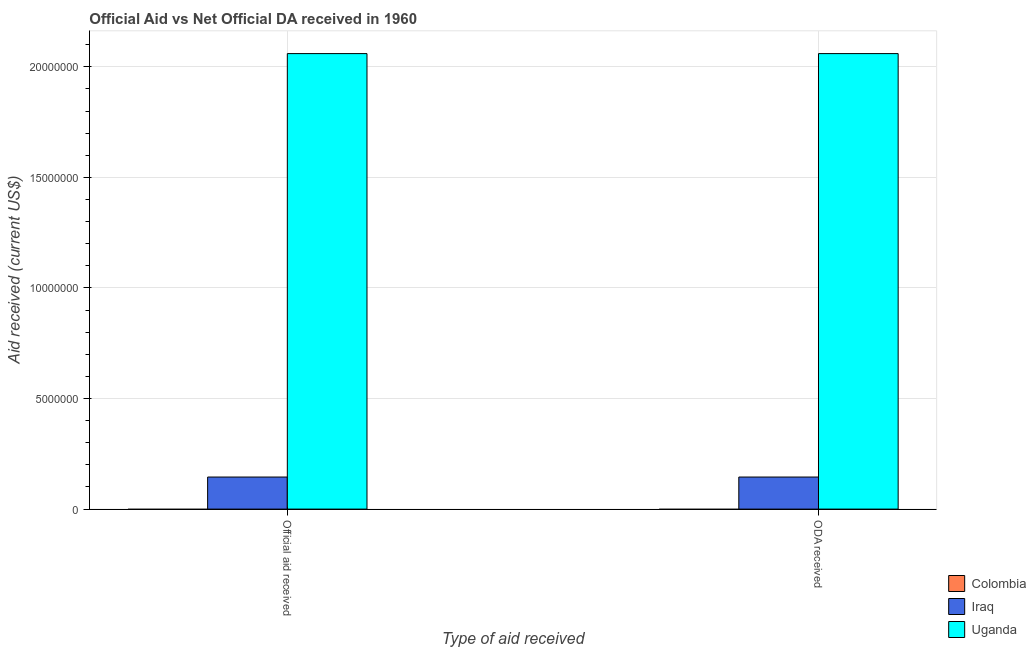Are the number of bars per tick equal to the number of legend labels?
Keep it short and to the point. No. How many bars are there on the 2nd tick from the left?
Provide a succinct answer. 2. How many bars are there on the 1st tick from the right?
Your answer should be compact. 2. What is the label of the 1st group of bars from the left?
Offer a terse response. Official aid received. What is the official aid received in Iraq?
Give a very brief answer. 1.45e+06. Across all countries, what is the maximum official aid received?
Make the answer very short. 2.06e+07. Across all countries, what is the minimum oda received?
Provide a short and direct response. 0. In which country was the oda received maximum?
Your answer should be very brief. Uganda. What is the total oda received in the graph?
Your answer should be compact. 2.20e+07. What is the difference between the official aid received in Iraq and that in Uganda?
Ensure brevity in your answer.  -1.92e+07. What is the difference between the oda received in Uganda and the official aid received in Iraq?
Give a very brief answer. 1.92e+07. What is the average official aid received per country?
Ensure brevity in your answer.  7.35e+06. What is the difference between the oda received and official aid received in Uganda?
Offer a terse response. 0. What is the ratio of the official aid received in Uganda to that in Iraq?
Provide a succinct answer. 14.21. In how many countries, is the oda received greater than the average oda received taken over all countries?
Your answer should be compact. 1. Are all the bars in the graph horizontal?
Give a very brief answer. No. How many countries are there in the graph?
Keep it short and to the point. 3. Does the graph contain any zero values?
Make the answer very short. Yes. Does the graph contain grids?
Give a very brief answer. Yes. How many legend labels are there?
Offer a very short reply. 3. What is the title of the graph?
Give a very brief answer. Official Aid vs Net Official DA received in 1960 . Does "Nigeria" appear as one of the legend labels in the graph?
Keep it short and to the point. No. What is the label or title of the X-axis?
Make the answer very short. Type of aid received. What is the label or title of the Y-axis?
Your answer should be very brief. Aid received (current US$). What is the Aid received (current US$) in Iraq in Official aid received?
Provide a short and direct response. 1.45e+06. What is the Aid received (current US$) in Uganda in Official aid received?
Your answer should be compact. 2.06e+07. What is the Aid received (current US$) of Iraq in ODA received?
Make the answer very short. 1.45e+06. What is the Aid received (current US$) of Uganda in ODA received?
Provide a short and direct response. 2.06e+07. Across all Type of aid received, what is the maximum Aid received (current US$) in Iraq?
Ensure brevity in your answer.  1.45e+06. Across all Type of aid received, what is the maximum Aid received (current US$) of Uganda?
Offer a terse response. 2.06e+07. Across all Type of aid received, what is the minimum Aid received (current US$) in Iraq?
Keep it short and to the point. 1.45e+06. Across all Type of aid received, what is the minimum Aid received (current US$) in Uganda?
Your answer should be very brief. 2.06e+07. What is the total Aid received (current US$) of Colombia in the graph?
Keep it short and to the point. 0. What is the total Aid received (current US$) of Iraq in the graph?
Your answer should be compact. 2.90e+06. What is the total Aid received (current US$) of Uganda in the graph?
Offer a terse response. 4.12e+07. What is the difference between the Aid received (current US$) of Iraq in Official aid received and the Aid received (current US$) of Uganda in ODA received?
Ensure brevity in your answer.  -1.92e+07. What is the average Aid received (current US$) in Colombia per Type of aid received?
Offer a terse response. 0. What is the average Aid received (current US$) in Iraq per Type of aid received?
Your answer should be very brief. 1.45e+06. What is the average Aid received (current US$) of Uganda per Type of aid received?
Your answer should be very brief. 2.06e+07. What is the difference between the Aid received (current US$) in Iraq and Aid received (current US$) in Uganda in Official aid received?
Offer a terse response. -1.92e+07. What is the difference between the Aid received (current US$) of Iraq and Aid received (current US$) of Uganda in ODA received?
Provide a succinct answer. -1.92e+07. What is the ratio of the Aid received (current US$) of Iraq in Official aid received to that in ODA received?
Make the answer very short. 1. What is the ratio of the Aid received (current US$) in Uganda in Official aid received to that in ODA received?
Provide a short and direct response. 1. What is the difference between the highest and the second highest Aid received (current US$) of Iraq?
Keep it short and to the point. 0. What is the difference between the highest and the second highest Aid received (current US$) in Uganda?
Offer a terse response. 0. What is the difference between the highest and the lowest Aid received (current US$) of Uganda?
Provide a succinct answer. 0. 